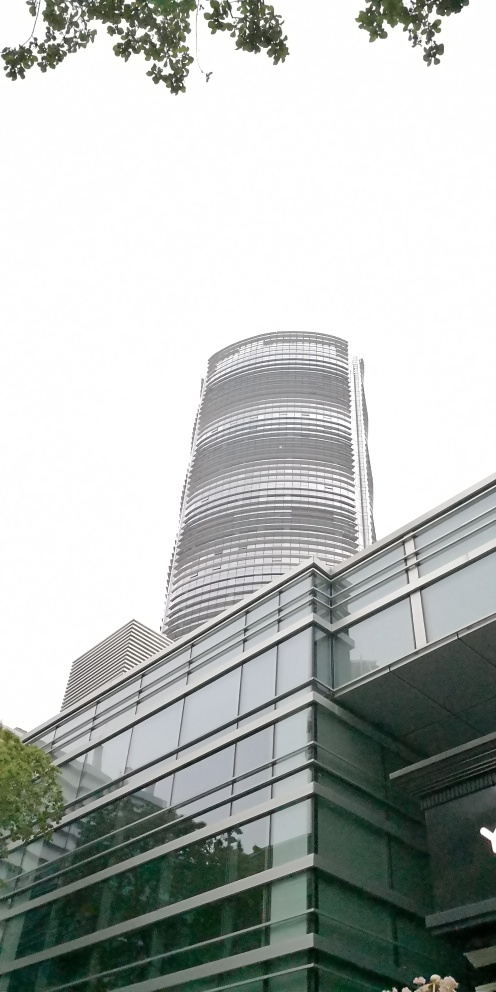What can we infer about the building's location within a city? Given the building's impressive height and modern facade, it's likely situated in a commercial district or downtown area of a city. The presence of mature trees at the top suggests access to a planned green space, possibly indicating an urban environment that values both development and nature. 